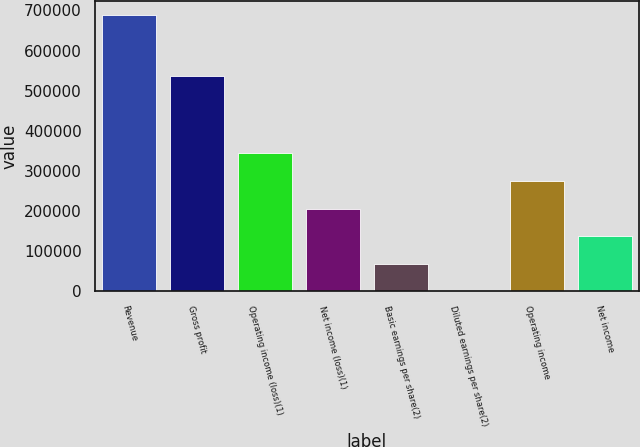Convert chart to OTSL. <chart><loc_0><loc_0><loc_500><loc_500><bar_chart><fcel>Revenue<fcel>Gross profit<fcel>Operating income (loss)(1)<fcel>Net income (loss)(1)<fcel>Basic earnings per share(2)<fcel>Diluted earnings per share(2)<fcel>Operating income<fcel>Net income<nl><fcel>687817<fcel>535874<fcel>343909<fcel>206345<fcel>68781.9<fcel>0.17<fcel>275127<fcel>137564<nl></chart> 